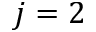<formula> <loc_0><loc_0><loc_500><loc_500>j = 2</formula> 